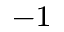<formula> <loc_0><loc_0><loc_500><loc_500>^ { - 1 }</formula> 